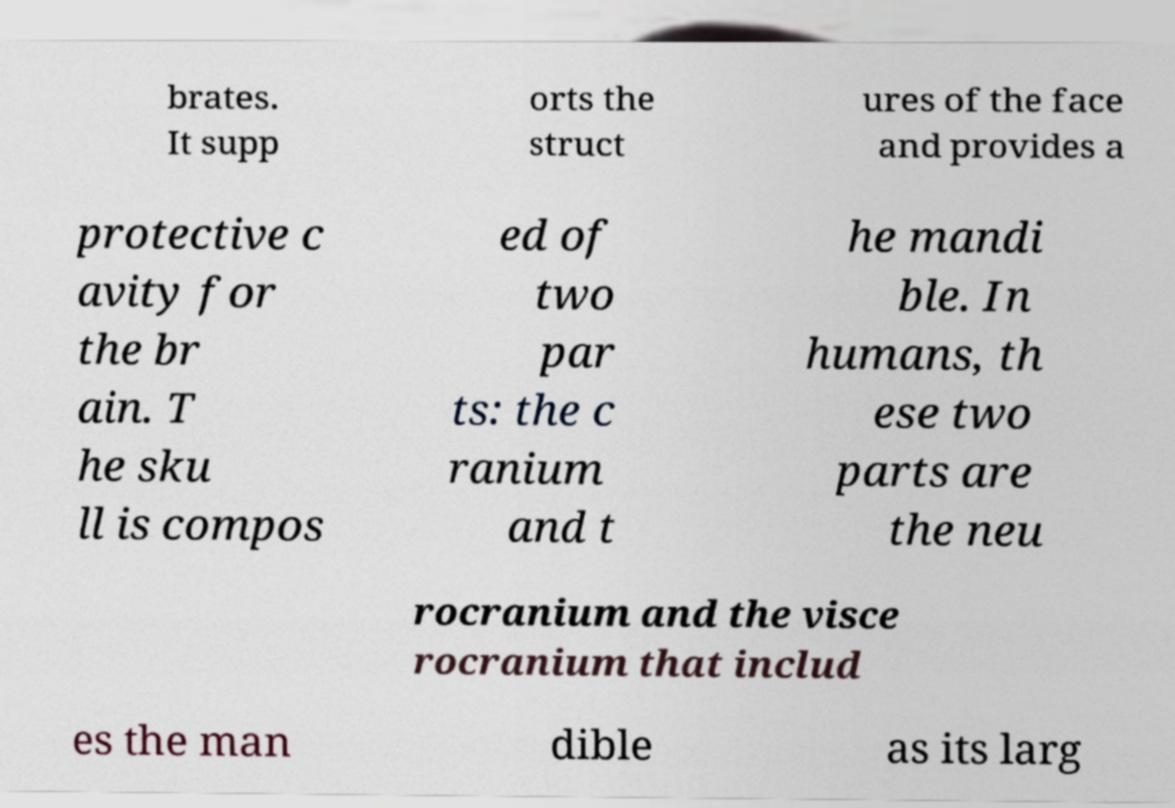I need the written content from this picture converted into text. Can you do that? brates. It supp orts the struct ures of the face and provides a protective c avity for the br ain. T he sku ll is compos ed of two par ts: the c ranium and t he mandi ble. In humans, th ese two parts are the neu rocranium and the visce rocranium that includ es the man dible as its larg 